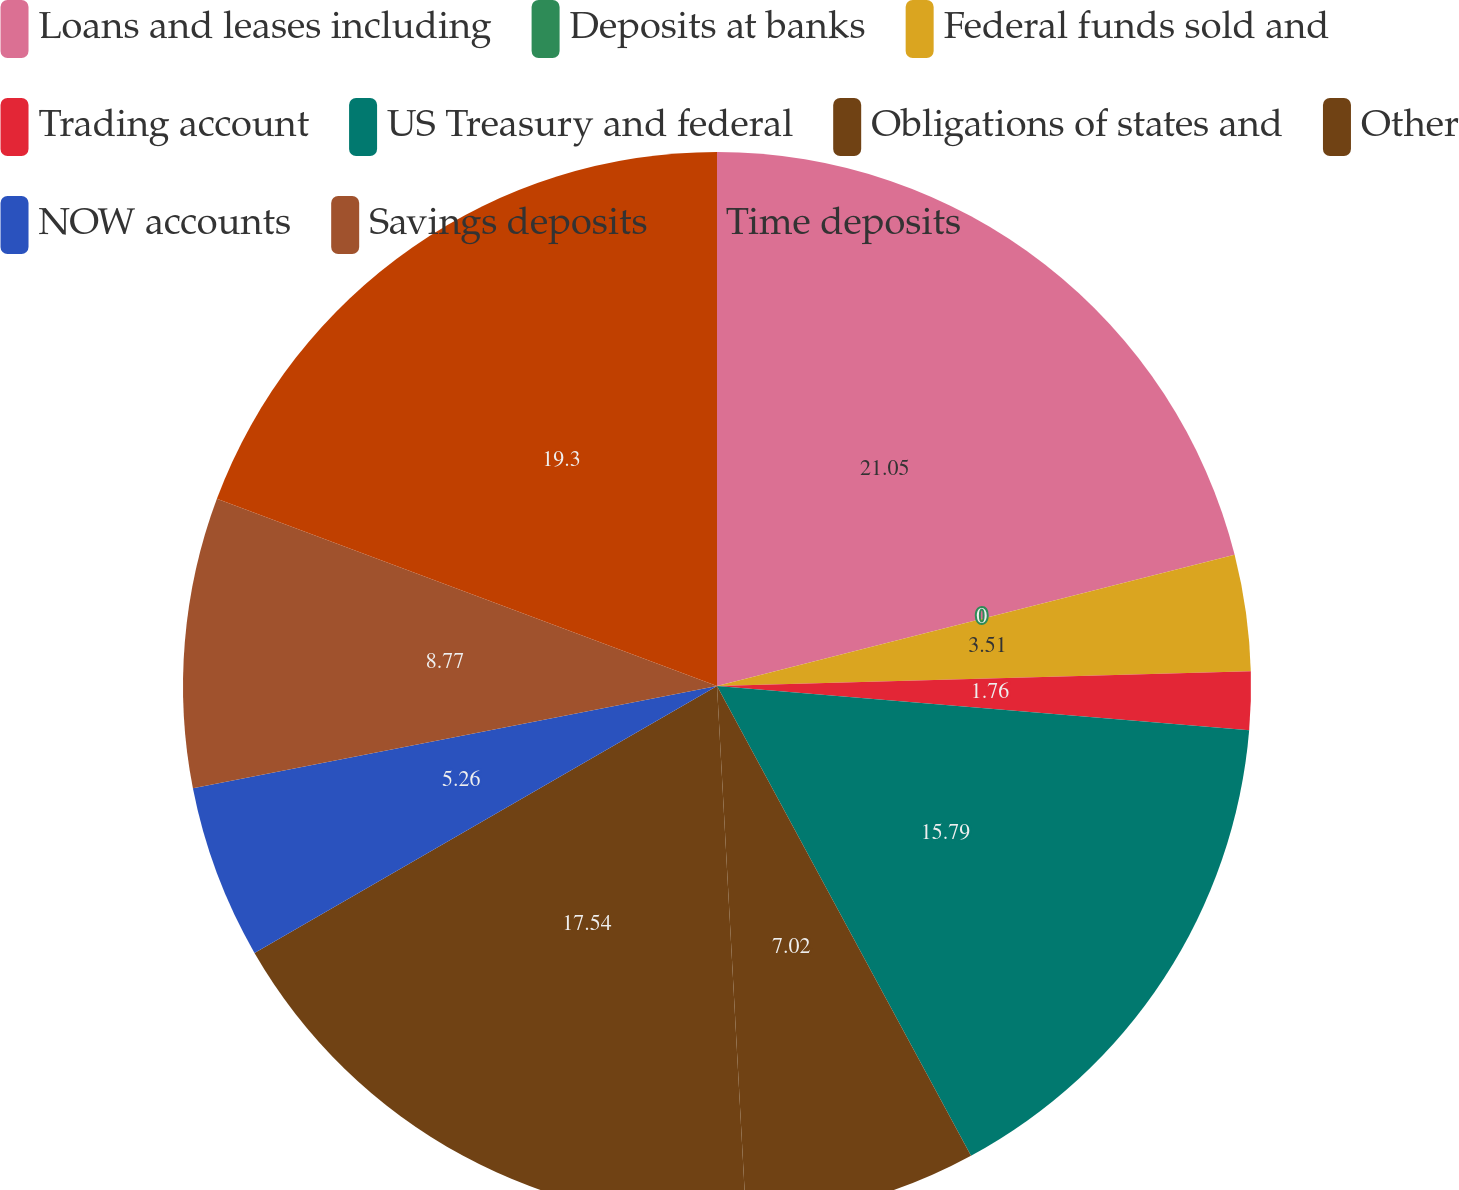Convert chart to OTSL. <chart><loc_0><loc_0><loc_500><loc_500><pie_chart><fcel>Loans and leases including<fcel>Deposits at banks<fcel>Federal funds sold and<fcel>Trading account<fcel>US Treasury and federal<fcel>Obligations of states and<fcel>Other<fcel>NOW accounts<fcel>Savings deposits<fcel>Time deposits<nl><fcel>21.05%<fcel>0.0%<fcel>3.51%<fcel>1.76%<fcel>15.79%<fcel>7.02%<fcel>17.54%<fcel>5.26%<fcel>8.77%<fcel>19.3%<nl></chart> 